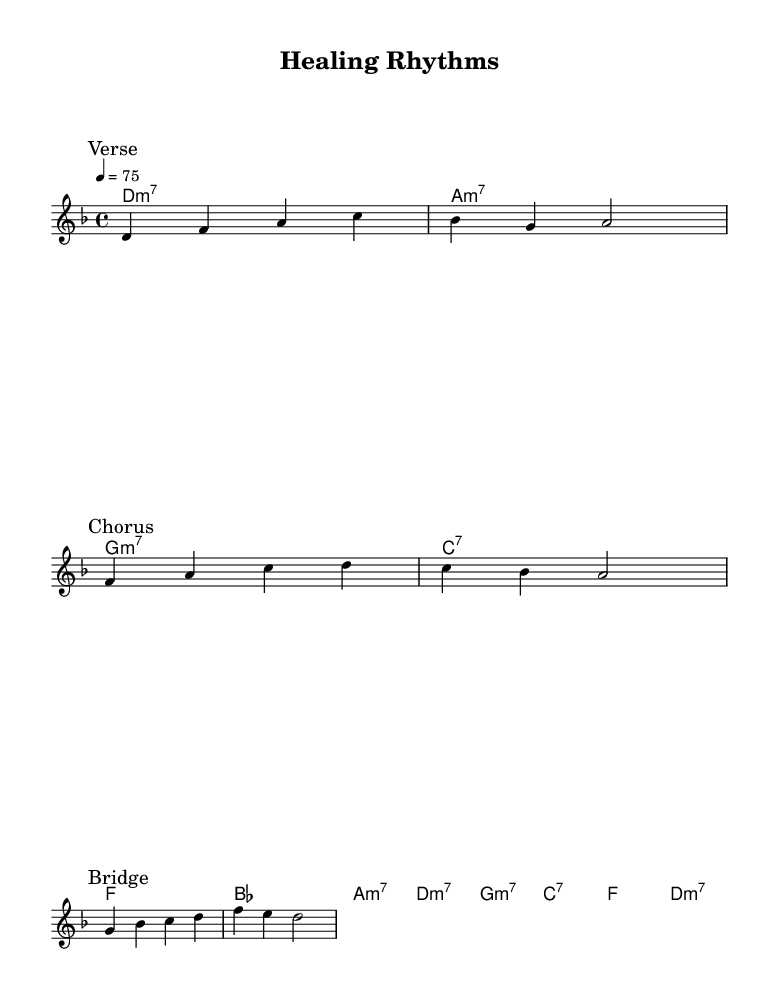What is the key signature of this music? The key signature is indicated by the key at the beginning of the score. Here, it shows D minor, which has one flat (B flat).
Answer: D minor What is the time signature of this piece? The time signature is found at the beginning of the score, specified in the format of beats per measure. In this case, it’s 4/4, meaning there are four beats in each measure.
Answer: 4/4 What is the tempo marking in this music? The tempo marking is displayed in terms of beats per minute (BPM). Here, it states "4 = 75," indicating the tempo for the quarter note is 75 beats per minute.
Answer: 75 How many sections are there in the melody? The score has three distinct sections labeled as "Verse", "Chorus", and "Bridge", which indicate different parts of the song's structure.
Answer: Three Which chord follows the "Chorus" section? The "Chorus" section ends with a chord progression that includes a C major chord. When inspecting the score, after the "Chorus," it transitions to the harmony indicated as C7 for the next chord.
Answer: C7 What lyric reflects the theme of healing? In the bridge section, the lyrics include the words “We're all heal -- ing,” which directly refer to the process of healing and emotional growth.
Answer: healing What type of emotional theme is evident in this piece? The piece addresses mental health awareness and emotional well-being, as shown in the lyrics that speak about reflection and learning to breathe through struggles, which resonates with the themes often found in neo-soul music.
Answer: Emotional well-being 